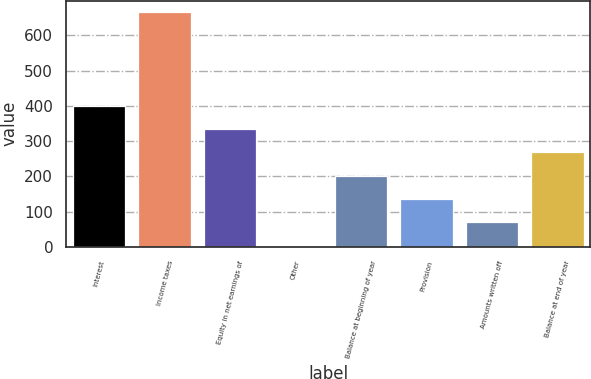Convert chart. <chart><loc_0><loc_0><loc_500><loc_500><bar_chart><fcel>Interest<fcel>Income taxes<fcel>Equity in net earnings of<fcel>Other<fcel>Balance at beginning of year<fcel>Provision<fcel>Amounts written off<fcel>Balance at end of year<nl><fcel>400.2<fcel>665<fcel>334<fcel>3<fcel>201.6<fcel>135.4<fcel>69.2<fcel>267.8<nl></chart> 